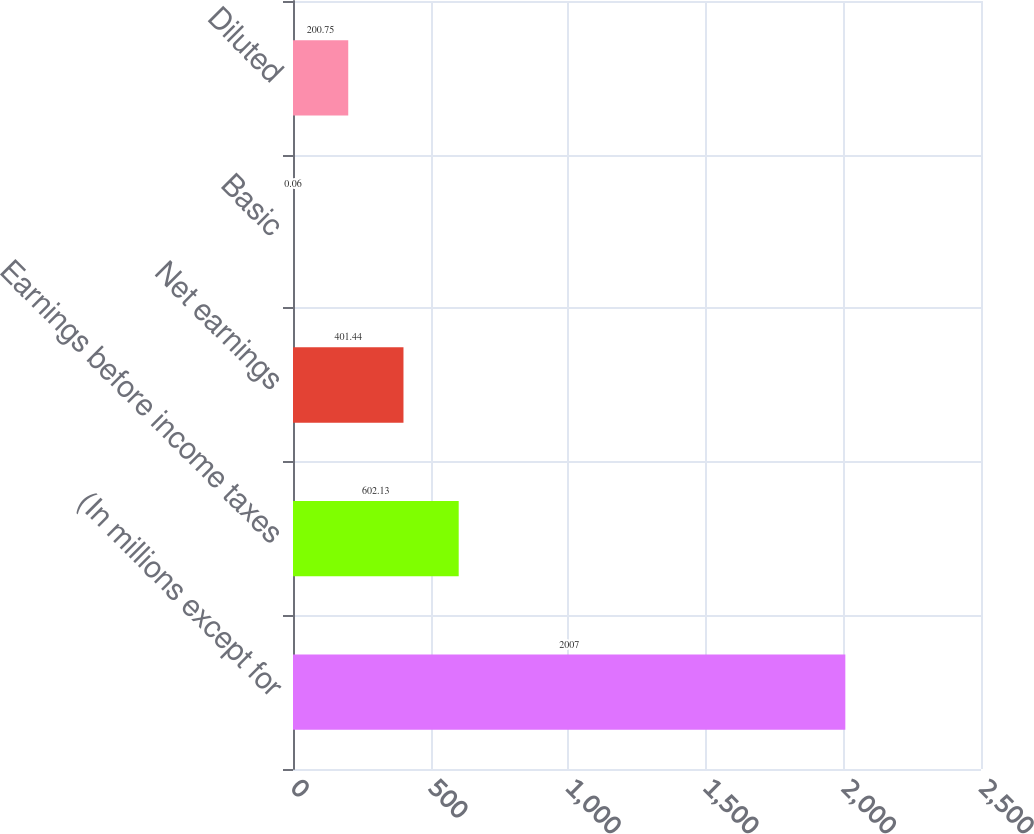<chart> <loc_0><loc_0><loc_500><loc_500><bar_chart><fcel>(In millions except for<fcel>Earnings before income taxes<fcel>Net earnings<fcel>Basic<fcel>Diluted<nl><fcel>2007<fcel>602.13<fcel>401.44<fcel>0.06<fcel>200.75<nl></chart> 